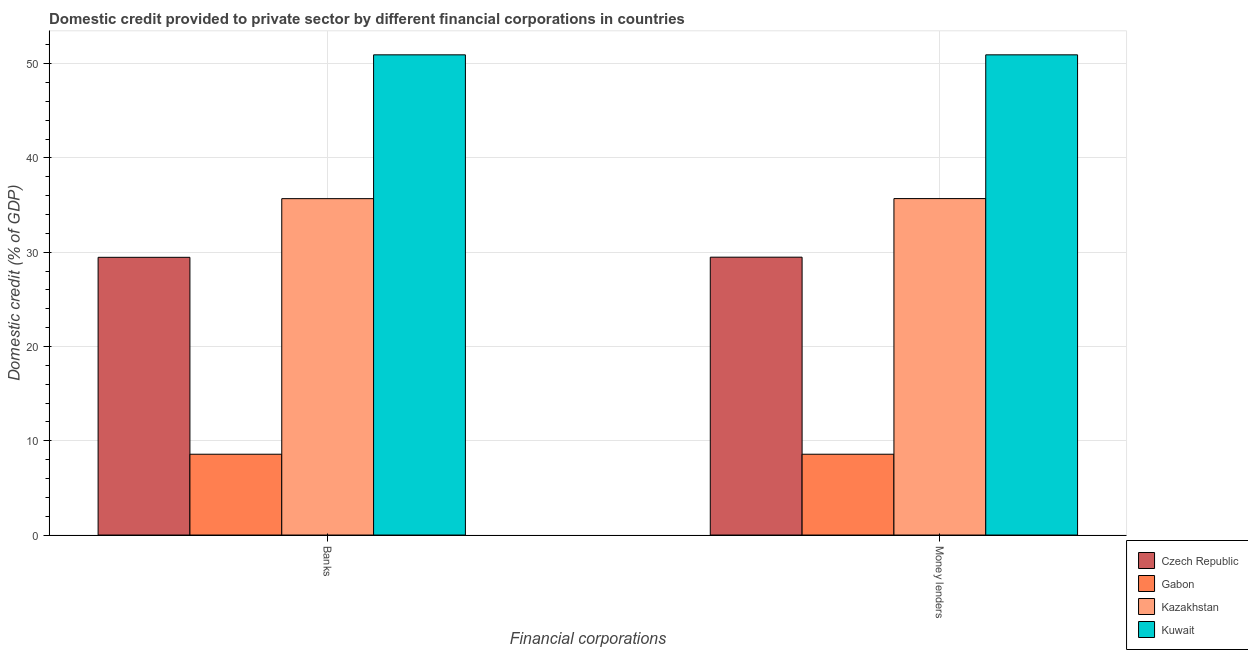How many groups of bars are there?
Ensure brevity in your answer.  2. How many bars are there on the 1st tick from the right?
Ensure brevity in your answer.  4. What is the label of the 1st group of bars from the left?
Ensure brevity in your answer.  Banks. What is the domestic credit provided by money lenders in Kazakhstan?
Provide a succinct answer. 35.69. Across all countries, what is the maximum domestic credit provided by banks?
Keep it short and to the point. 50.93. Across all countries, what is the minimum domestic credit provided by money lenders?
Make the answer very short. 8.57. In which country was the domestic credit provided by money lenders maximum?
Provide a succinct answer. Kuwait. In which country was the domestic credit provided by banks minimum?
Your response must be concise. Gabon. What is the total domestic credit provided by banks in the graph?
Your response must be concise. 124.64. What is the difference between the domestic credit provided by banks in Gabon and that in Czech Republic?
Provide a short and direct response. -20.88. What is the difference between the domestic credit provided by banks in Kazakhstan and the domestic credit provided by money lenders in Czech Republic?
Make the answer very short. 6.21. What is the average domestic credit provided by money lenders per country?
Provide a short and direct response. 31.17. What is the difference between the domestic credit provided by banks and domestic credit provided by money lenders in Gabon?
Provide a succinct answer. 0. In how many countries, is the domestic credit provided by banks greater than 34 %?
Keep it short and to the point. 2. What is the ratio of the domestic credit provided by banks in Kazakhstan to that in Czech Republic?
Give a very brief answer. 1.21. Is the domestic credit provided by money lenders in Gabon less than that in Czech Republic?
Your answer should be compact. Yes. What does the 3rd bar from the left in Money lenders represents?
Provide a succinct answer. Kazakhstan. What does the 2nd bar from the right in Banks represents?
Provide a succinct answer. Kazakhstan. How many bars are there?
Provide a succinct answer. 8. What is the difference between two consecutive major ticks on the Y-axis?
Make the answer very short. 10. Are the values on the major ticks of Y-axis written in scientific E-notation?
Make the answer very short. No. Does the graph contain any zero values?
Provide a succinct answer. No. Does the graph contain grids?
Make the answer very short. Yes. What is the title of the graph?
Make the answer very short. Domestic credit provided to private sector by different financial corporations in countries. What is the label or title of the X-axis?
Keep it short and to the point. Financial corporations. What is the label or title of the Y-axis?
Give a very brief answer. Domestic credit (% of GDP). What is the Domestic credit (% of GDP) in Czech Republic in Banks?
Your response must be concise. 29.46. What is the Domestic credit (% of GDP) of Gabon in Banks?
Your response must be concise. 8.57. What is the Domestic credit (% of GDP) in Kazakhstan in Banks?
Ensure brevity in your answer.  35.68. What is the Domestic credit (% of GDP) of Kuwait in Banks?
Your answer should be very brief. 50.93. What is the Domestic credit (% of GDP) of Czech Republic in Money lenders?
Offer a terse response. 29.47. What is the Domestic credit (% of GDP) of Gabon in Money lenders?
Give a very brief answer. 8.57. What is the Domestic credit (% of GDP) in Kazakhstan in Money lenders?
Your answer should be very brief. 35.69. What is the Domestic credit (% of GDP) of Kuwait in Money lenders?
Give a very brief answer. 50.93. Across all Financial corporations, what is the maximum Domestic credit (% of GDP) of Czech Republic?
Give a very brief answer. 29.47. Across all Financial corporations, what is the maximum Domestic credit (% of GDP) in Gabon?
Provide a short and direct response. 8.57. Across all Financial corporations, what is the maximum Domestic credit (% of GDP) in Kazakhstan?
Your answer should be very brief. 35.69. Across all Financial corporations, what is the maximum Domestic credit (% of GDP) in Kuwait?
Give a very brief answer. 50.93. Across all Financial corporations, what is the minimum Domestic credit (% of GDP) of Czech Republic?
Offer a terse response. 29.46. Across all Financial corporations, what is the minimum Domestic credit (% of GDP) in Gabon?
Ensure brevity in your answer.  8.57. Across all Financial corporations, what is the minimum Domestic credit (% of GDP) in Kazakhstan?
Keep it short and to the point. 35.68. Across all Financial corporations, what is the minimum Domestic credit (% of GDP) of Kuwait?
Your answer should be very brief. 50.93. What is the total Domestic credit (% of GDP) in Czech Republic in the graph?
Your response must be concise. 58.93. What is the total Domestic credit (% of GDP) of Gabon in the graph?
Offer a terse response. 17.14. What is the total Domestic credit (% of GDP) in Kazakhstan in the graph?
Make the answer very short. 71.37. What is the total Domestic credit (% of GDP) in Kuwait in the graph?
Your response must be concise. 101.87. What is the difference between the Domestic credit (% of GDP) of Czech Republic in Banks and that in Money lenders?
Offer a very short reply. -0.02. What is the difference between the Domestic credit (% of GDP) of Kazakhstan in Banks and that in Money lenders?
Keep it short and to the point. -0.01. What is the difference between the Domestic credit (% of GDP) in Kuwait in Banks and that in Money lenders?
Your answer should be compact. 0. What is the difference between the Domestic credit (% of GDP) of Czech Republic in Banks and the Domestic credit (% of GDP) of Gabon in Money lenders?
Give a very brief answer. 20.88. What is the difference between the Domestic credit (% of GDP) of Czech Republic in Banks and the Domestic credit (% of GDP) of Kazakhstan in Money lenders?
Your answer should be compact. -6.23. What is the difference between the Domestic credit (% of GDP) of Czech Republic in Banks and the Domestic credit (% of GDP) of Kuwait in Money lenders?
Offer a terse response. -21.48. What is the difference between the Domestic credit (% of GDP) of Gabon in Banks and the Domestic credit (% of GDP) of Kazakhstan in Money lenders?
Provide a short and direct response. -27.11. What is the difference between the Domestic credit (% of GDP) of Gabon in Banks and the Domestic credit (% of GDP) of Kuwait in Money lenders?
Provide a short and direct response. -42.36. What is the difference between the Domestic credit (% of GDP) of Kazakhstan in Banks and the Domestic credit (% of GDP) of Kuwait in Money lenders?
Make the answer very short. -15.25. What is the average Domestic credit (% of GDP) of Czech Republic per Financial corporations?
Ensure brevity in your answer.  29.46. What is the average Domestic credit (% of GDP) in Gabon per Financial corporations?
Offer a very short reply. 8.57. What is the average Domestic credit (% of GDP) of Kazakhstan per Financial corporations?
Give a very brief answer. 35.68. What is the average Domestic credit (% of GDP) of Kuwait per Financial corporations?
Offer a terse response. 50.93. What is the difference between the Domestic credit (% of GDP) of Czech Republic and Domestic credit (% of GDP) of Gabon in Banks?
Offer a very short reply. 20.88. What is the difference between the Domestic credit (% of GDP) of Czech Republic and Domestic credit (% of GDP) of Kazakhstan in Banks?
Your answer should be compact. -6.22. What is the difference between the Domestic credit (% of GDP) of Czech Republic and Domestic credit (% of GDP) of Kuwait in Banks?
Offer a very short reply. -21.48. What is the difference between the Domestic credit (% of GDP) of Gabon and Domestic credit (% of GDP) of Kazakhstan in Banks?
Give a very brief answer. -27.11. What is the difference between the Domestic credit (% of GDP) of Gabon and Domestic credit (% of GDP) of Kuwait in Banks?
Your response must be concise. -42.36. What is the difference between the Domestic credit (% of GDP) in Kazakhstan and Domestic credit (% of GDP) in Kuwait in Banks?
Provide a succinct answer. -15.25. What is the difference between the Domestic credit (% of GDP) in Czech Republic and Domestic credit (% of GDP) in Gabon in Money lenders?
Your answer should be compact. 20.9. What is the difference between the Domestic credit (% of GDP) in Czech Republic and Domestic credit (% of GDP) in Kazakhstan in Money lenders?
Provide a succinct answer. -6.21. What is the difference between the Domestic credit (% of GDP) of Czech Republic and Domestic credit (% of GDP) of Kuwait in Money lenders?
Your answer should be compact. -21.46. What is the difference between the Domestic credit (% of GDP) in Gabon and Domestic credit (% of GDP) in Kazakhstan in Money lenders?
Your answer should be compact. -27.11. What is the difference between the Domestic credit (% of GDP) in Gabon and Domestic credit (% of GDP) in Kuwait in Money lenders?
Provide a succinct answer. -42.36. What is the difference between the Domestic credit (% of GDP) of Kazakhstan and Domestic credit (% of GDP) of Kuwait in Money lenders?
Give a very brief answer. -15.25. What is the ratio of the Domestic credit (% of GDP) of Czech Republic in Banks to that in Money lenders?
Keep it short and to the point. 1. What is the ratio of the Domestic credit (% of GDP) in Gabon in Banks to that in Money lenders?
Your answer should be very brief. 1. What is the ratio of the Domestic credit (% of GDP) in Kazakhstan in Banks to that in Money lenders?
Give a very brief answer. 1. What is the ratio of the Domestic credit (% of GDP) in Kuwait in Banks to that in Money lenders?
Offer a very short reply. 1. What is the difference between the highest and the second highest Domestic credit (% of GDP) of Czech Republic?
Make the answer very short. 0.02. What is the difference between the highest and the second highest Domestic credit (% of GDP) in Gabon?
Your response must be concise. 0. What is the difference between the highest and the second highest Domestic credit (% of GDP) in Kazakhstan?
Offer a terse response. 0.01. What is the difference between the highest and the second highest Domestic credit (% of GDP) in Kuwait?
Ensure brevity in your answer.  0. What is the difference between the highest and the lowest Domestic credit (% of GDP) in Czech Republic?
Offer a terse response. 0.02. What is the difference between the highest and the lowest Domestic credit (% of GDP) in Kazakhstan?
Offer a terse response. 0.01. 